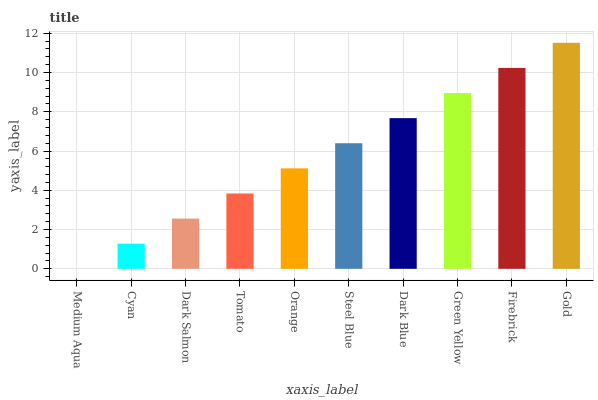Is Medium Aqua the minimum?
Answer yes or no. Yes. Is Gold the maximum?
Answer yes or no. Yes. Is Cyan the minimum?
Answer yes or no. No. Is Cyan the maximum?
Answer yes or no. No. Is Cyan greater than Medium Aqua?
Answer yes or no. Yes. Is Medium Aqua less than Cyan?
Answer yes or no. Yes. Is Medium Aqua greater than Cyan?
Answer yes or no. No. Is Cyan less than Medium Aqua?
Answer yes or no. No. Is Steel Blue the high median?
Answer yes or no. Yes. Is Orange the low median?
Answer yes or no. Yes. Is Cyan the high median?
Answer yes or no. No. Is Medium Aqua the low median?
Answer yes or no. No. 